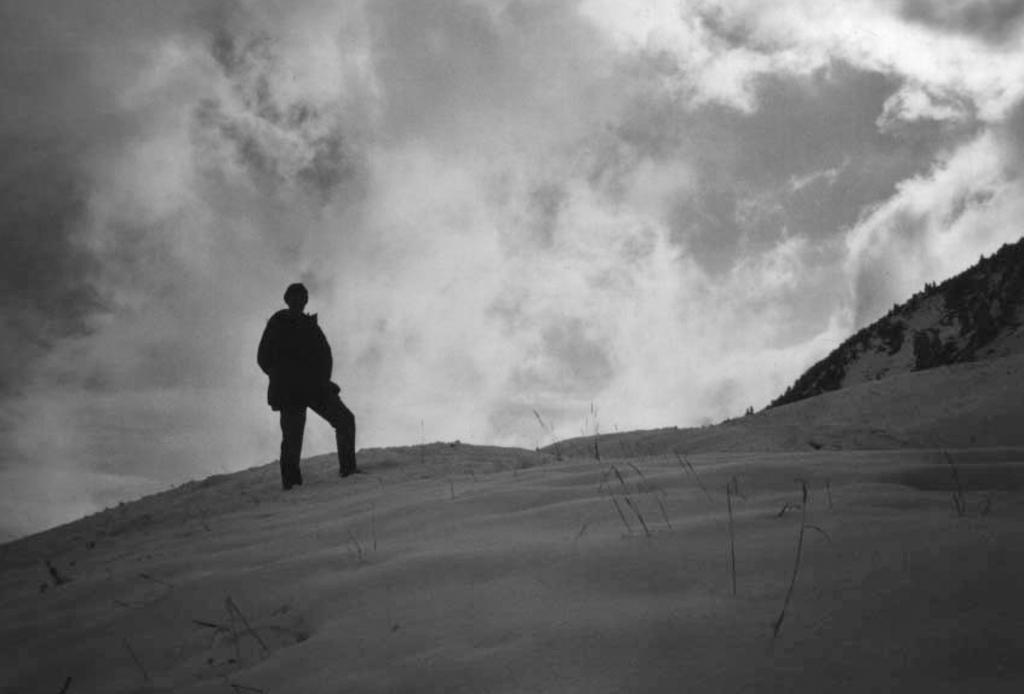What is the color scheme of the image? The image is black and white. Who or what can be seen in the image? There is a man standing in the image. Where is the man standing? The man is standing on a hill. What is visible in the background of the image? There is a sky visible in the background of the image. What is the name of the wilderness area where the man is standing in the image? There is no specific wilderness area mentioned or identifiable in the image, as it is a black and white image of a man standing on a hill with a sky in the background. 